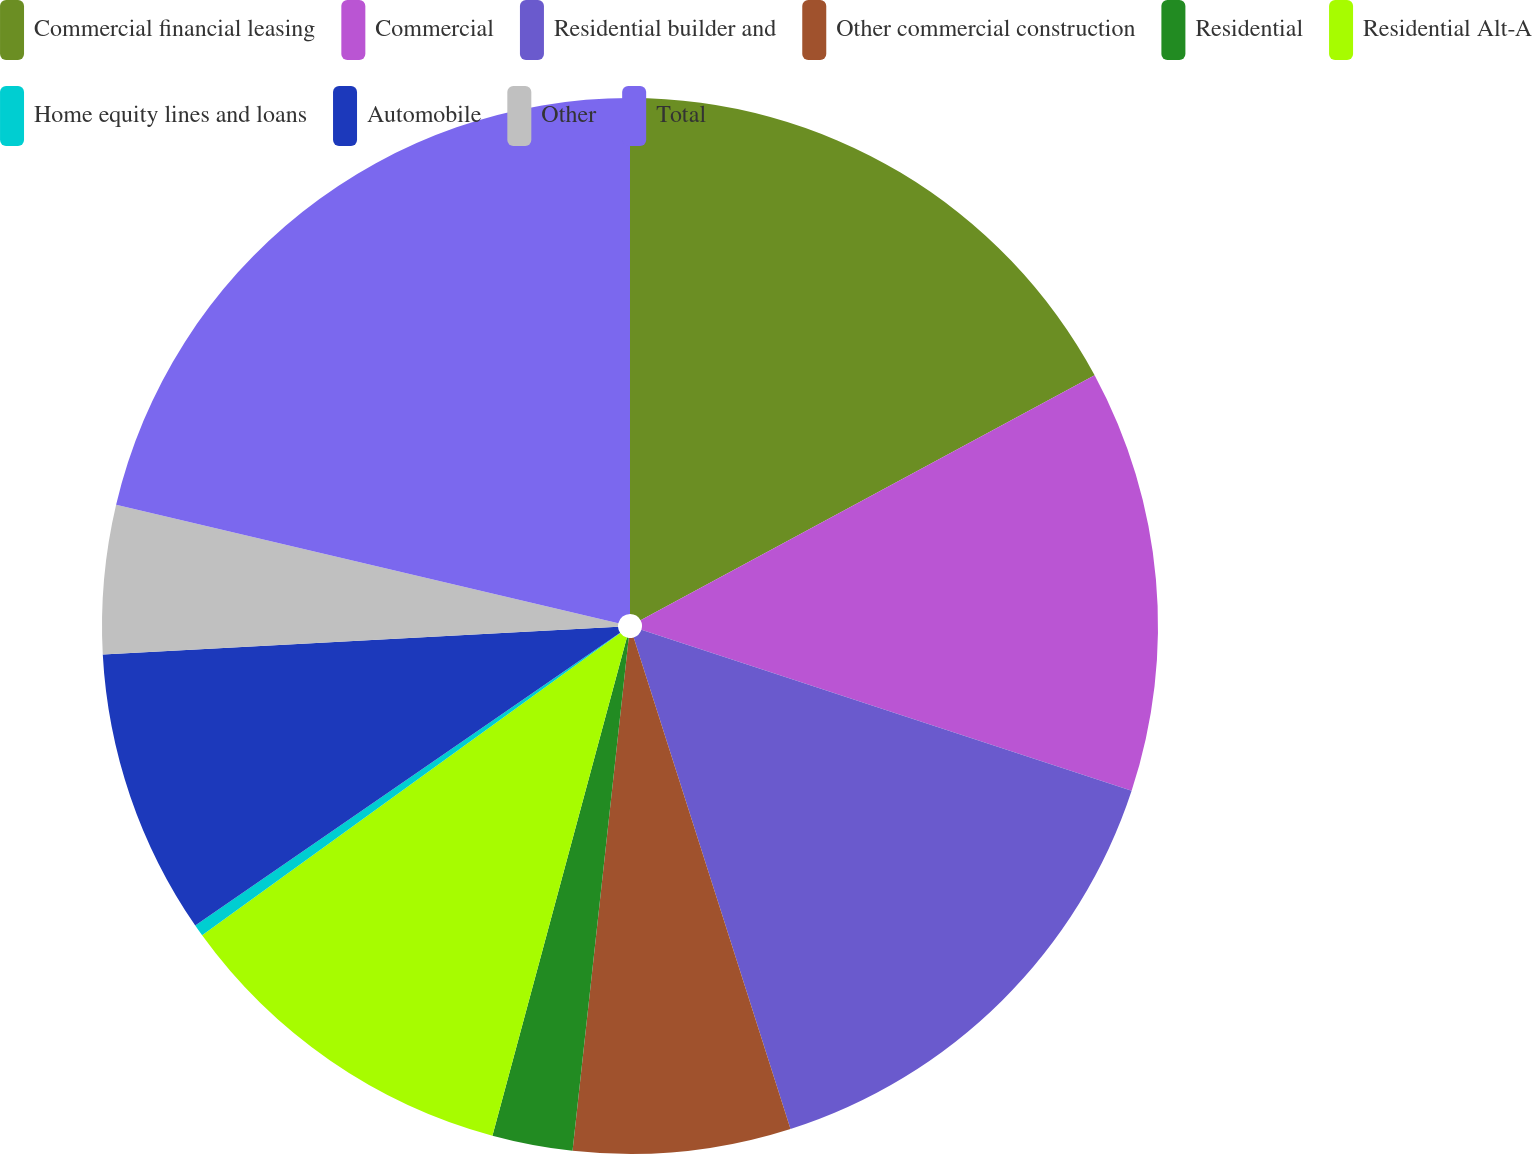Convert chart. <chart><loc_0><loc_0><loc_500><loc_500><pie_chart><fcel>Commercial financial leasing<fcel>Commercial<fcel>Residential builder and<fcel>Other commercial construction<fcel>Residential<fcel>Residential Alt-A<fcel>Home equity lines and loans<fcel>Automobile<fcel>Other<fcel>Total<nl><fcel>17.12%<fcel>12.93%<fcel>15.03%<fcel>6.65%<fcel>2.46%<fcel>10.84%<fcel>0.36%<fcel>8.74%<fcel>4.55%<fcel>21.31%<nl></chart> 